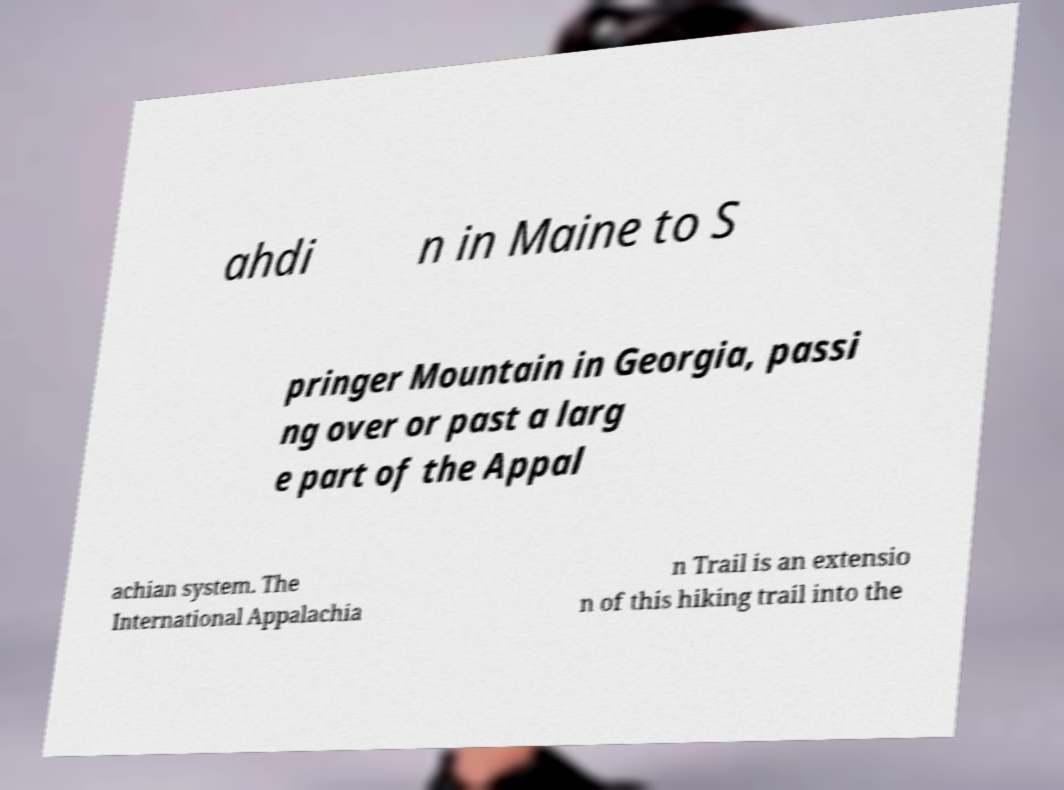I need the written content from this picture converted into text. Can you do that? ahdi n in Maine to S pringer Mountain in Georgia, passi ng over or past a larg e part of the Appal achian system. The International Appalachia n Trail is an extensio n of this hiking trail into the 